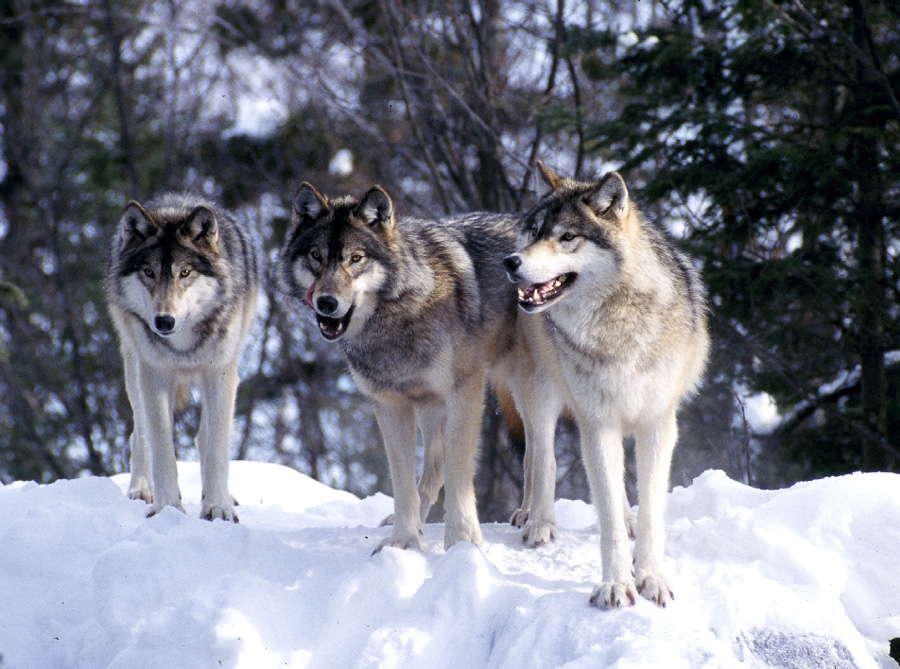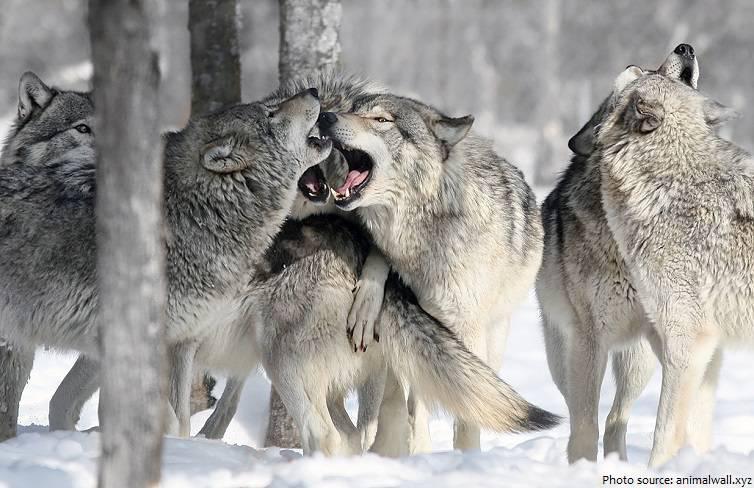The first image is the image on the left, the second image is the image on the right. For the images displayed, is the sentence "In the right image, there are four wolves in the snow." factually correct? Answer yes or no. No. 